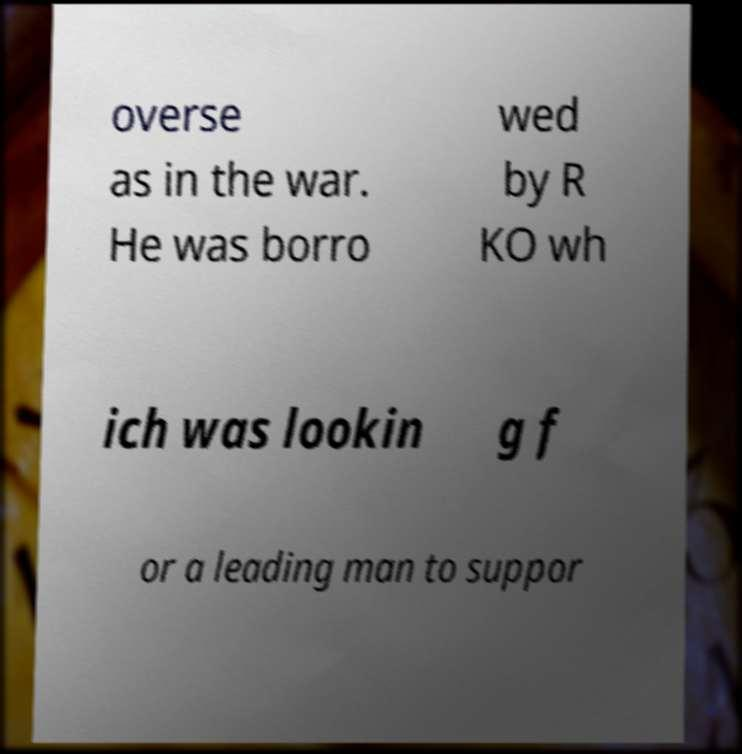Can you read and provide the text displayed in the image?This photo seems to have some interesting text. Can you extract and type it out for me? overse as in the war. He was borro wed by R KO wh ich was lookin g f or a leading man to suppor 